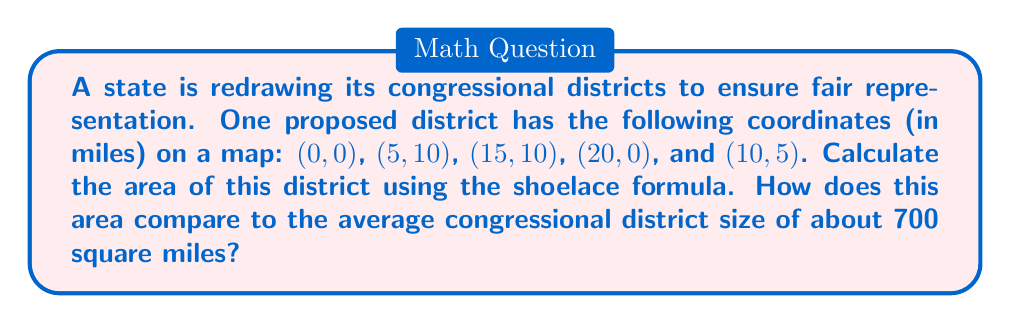What is the answer to this math problem? Let's solve this step-by-step using the shoelace formula:

1) The shoelace formula for the area of a polygon is:

   $$A = \frac{1}{2}|\sum_{i=1}^{n-1} (x_iy_{i+1} + x_ny_1) - \sum_{i=1}^{n-1} (y_ix_{i+1} + y_nx_1)|$$

2) We have the following coordinates:
   $(x_1,y_1) = (0,0)$
   $(x_2,y_2) = (5,10)$
   $(x_3,y_3) = (15,10)$
   $(x_4,y_4) = (20,0)$
   $(x_5,y_5) = (10,5)$

3) Let's calculate the first sum:
   $$(0 \cdot 10) + (5 \cdot 10) + (15 \cdot 0) + (20 \cdot 5) + (10 \cdot 0) = 0 + 50 + 0 + 100 + 0 = 150$$

4) Now the second sum:
   $$(0 \cdot 5) + (10 \cdot 15) + (10 \cdot 20) + (0 \cdot 10) + (5 \cdot 0) = 0 + 150 + 200 + 0 + 0 = 350$$

5) Subtracting and taking the absolute value:
   $$|150 - 350| = 200$$

6) Multiplying by $\frac{1}{2}$:
   $$\frac{1}{2} \cdot 200 = 100$$

Therefore, the area of the district is 100 square miles.

Comparing to the average district size of 700 square miles, this district is significantly smaller, only about 14.3% of the average size.
Answer: 100 square miles 